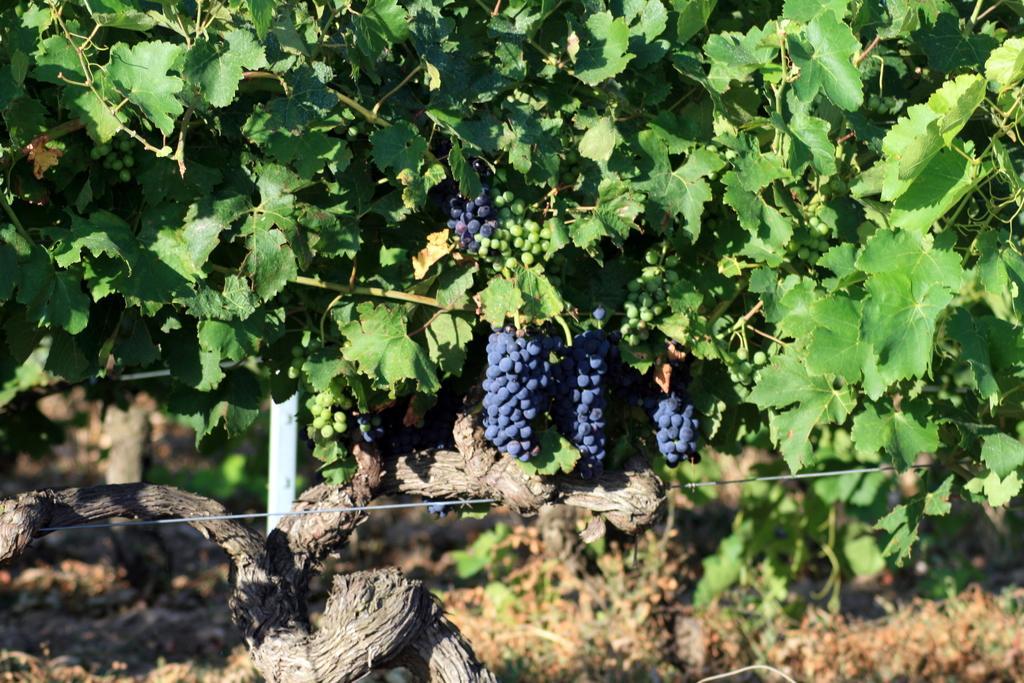Can you describe this image briefly? In the picture there is a grape tree there are two types of grapes to that tree, the background of the tree is blur. 